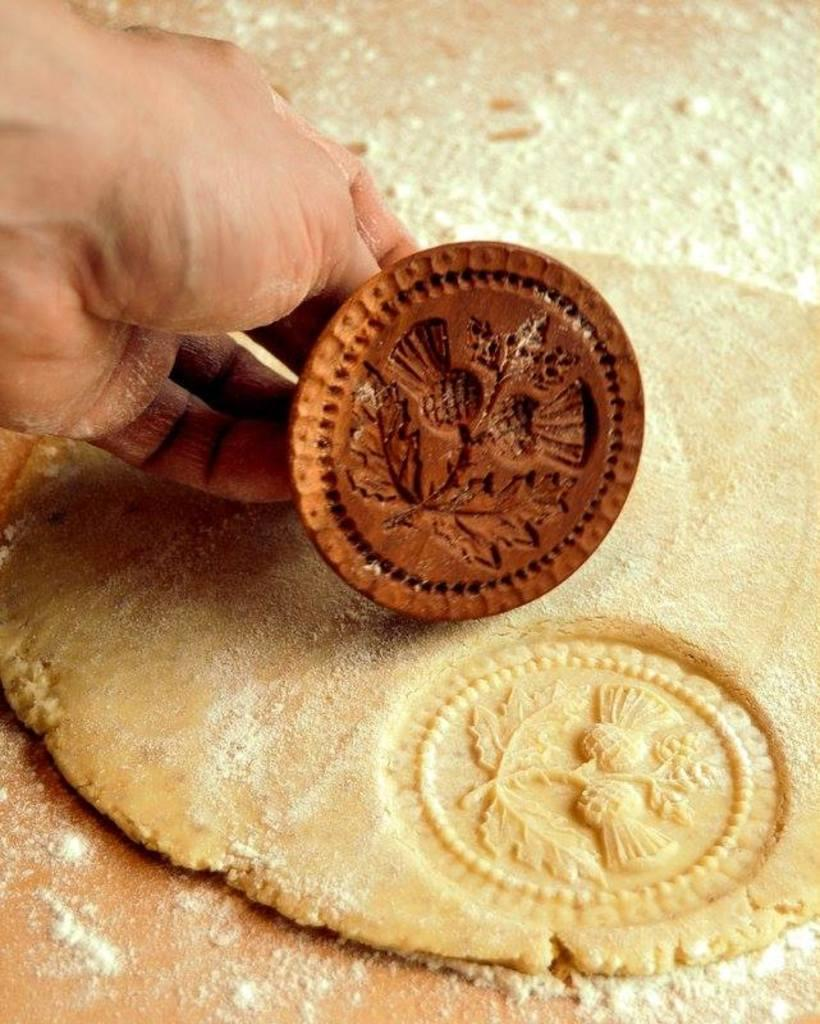What part of the human body can be seen in the image? There is a human hand in the image. What is the hand doing in the image? The hand is using tools in the image. What is the substance on the surface in the image? There is dough on a surface in the image. What is added to the dough in the image? Dusting powder is present on the dough. How many wrens can be seen flying around the dough in the image? There are no wrens present in the image; it only features a human hand, tools, dough, and dusting powder. 